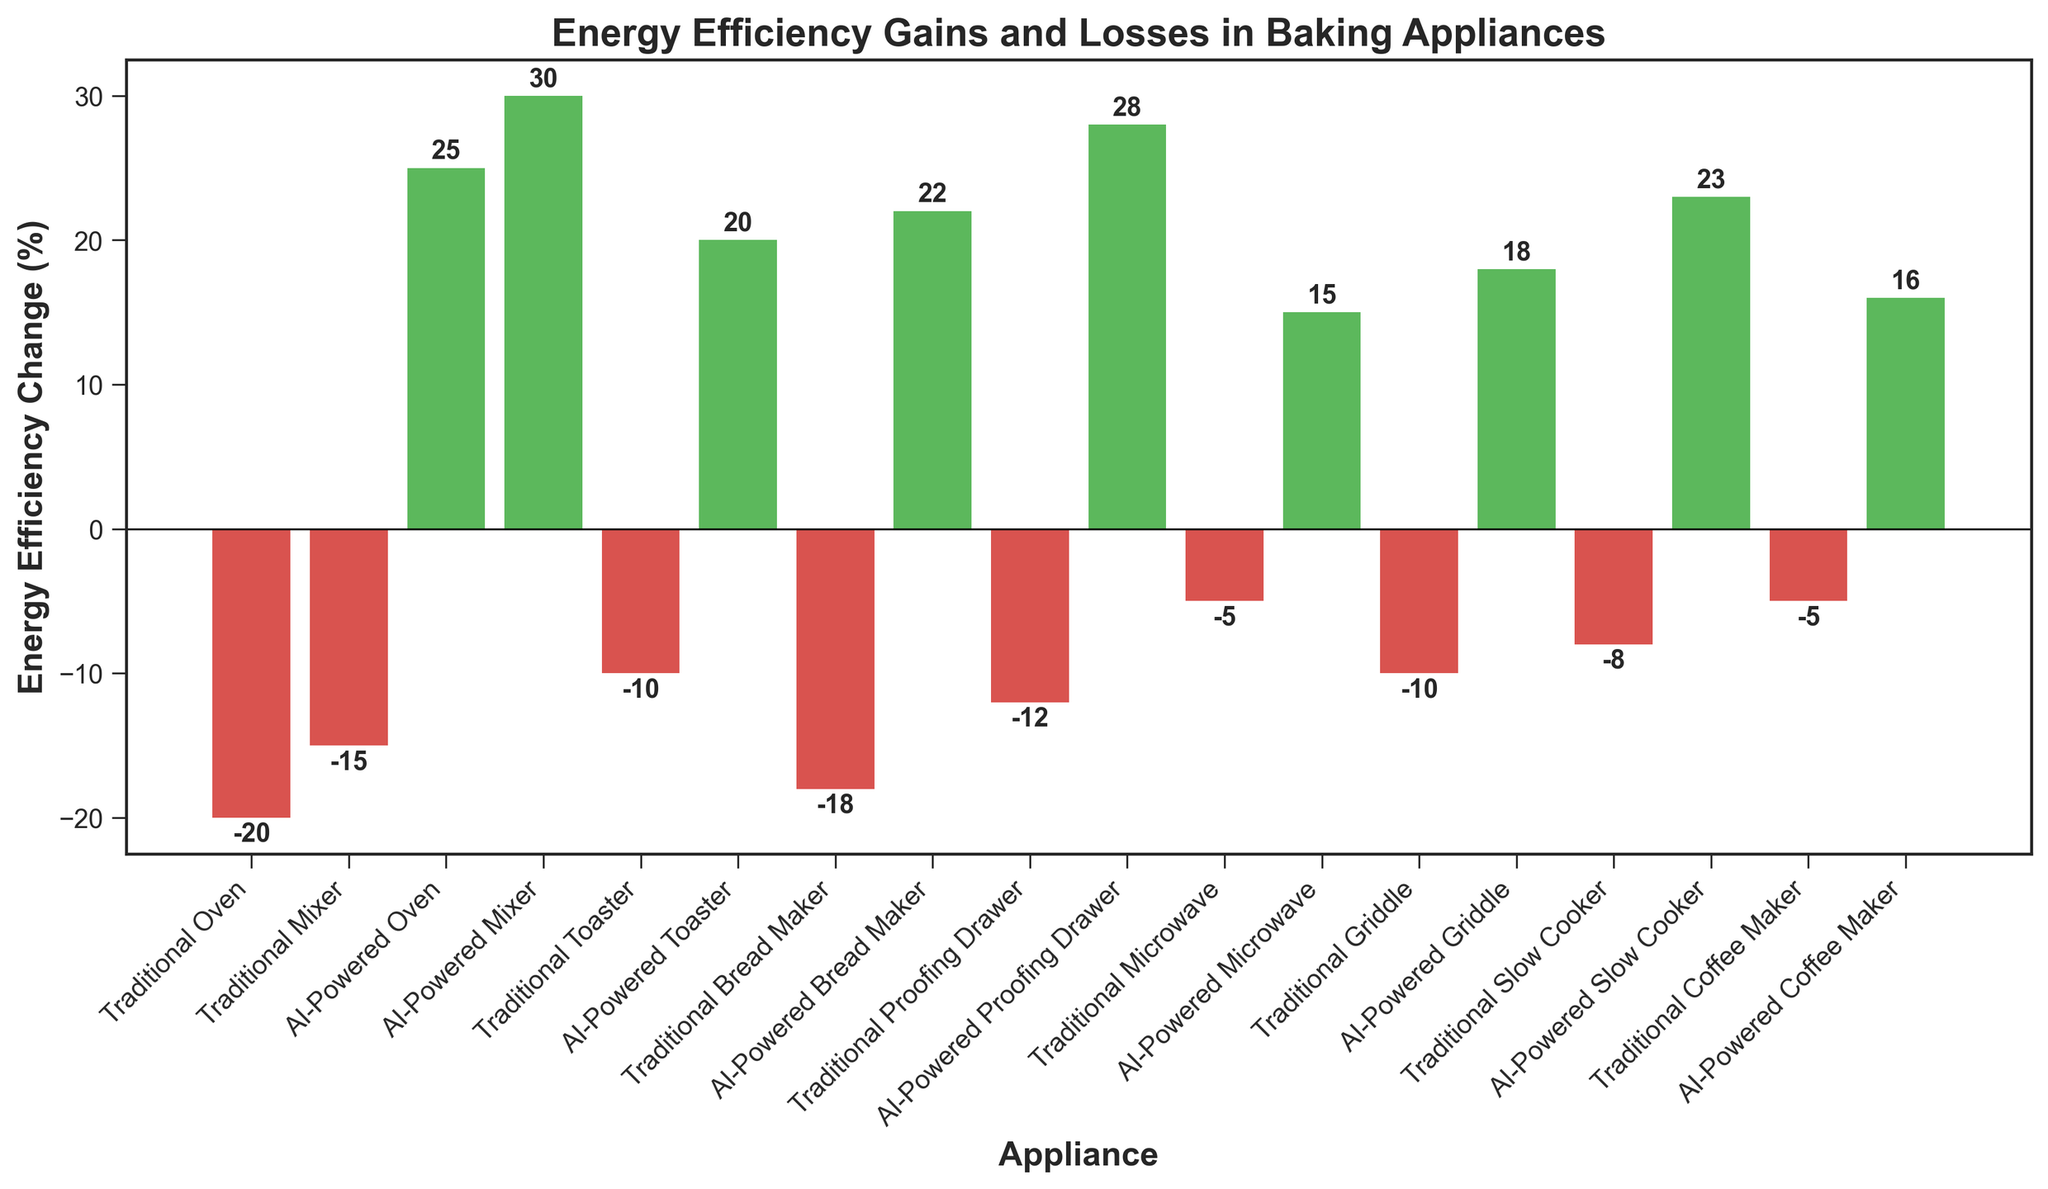Which appliance has the highest positive energy efficiency change? The bar for the AI-Powered Mixer is the tallest among all green-colored bars, indicating the highest positive change.
Answer: AI-Powered Mixer Which traditional appliance has the greatest loss in energy efficiency? The bar for the Traditional Oven has the lowest height among all the red-colored bars, indicating the most significant loss.
Answer: Traditional Oven What is the total energy efficiency change for AI-Powered Baking Appliances? Sum the energy efficiency changes for all AI-Powered appliances: 25 + 30 + 20 + 22 + 28 + 15 + 18 + 23 + 16 = 197
Answer: 197 What is the difference in energy efficiency change between the AI-Powered Oven and the Traditional Oven? Find the value for AI-Powered Oven (25) and subtract the value for Traditional Oven (-20), 25 - (-20) = 25 + 20 = 45
Answer: 45 Does any traditional appliance show a positive energy efficiency change? All red-colored bars represent traditional appliances with negative values indicating a decrease in energy efficiency; none show a positive change.
Answer: No Which appliance shows the highest energy efficiency gain and what is its value? The highest green-colored bar represents the AI-Powered Mixer with a value of 30%.
Answer: AI-Powered Mixer, 30% What is the average energy efficiency change for all traditional appliances? Calculate the average by summing all traditional appliance values and dividing by their count: (-20 - 15 - 10 - 18 - 12 - 5 - 10 - 8 - 5) / 9 = -103 / 9 ≈ -11.44
Answer: -11.44 How many AI-powered appliances have energy efficiency gains greater than 20%? Identify bars corresponding to AI-powered appliances with values greater than 20%: AI-Powered Mixer (30), AI-Powered Bread Maker (22), AI-Powered Proofing Drawer (28), AI-Powered Slow Cooker (23) – total 4 appliances.
Answer: 4 